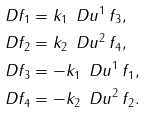<formula> <loc_0><loc_0><loc_500><loc_500>\ D f _ { 1 } & = k _ { 1 } \, \ D u ^ { 1 } \, f _ { 3 } , \\ \ D f _ { 2 } & = k _ { 2 } \, \ D u ^ { 2 } \, f _ { 4 } , \\ \ D f _ { 3 } & = - k _ { 1 } \, \ D u ^ { 1 } \, f _ { 1 } , \\ \ D f _ { 4 } & = - k _ { 2 } \, \ D u ^ { 2 } \, f _ { 2 } .</formula> 